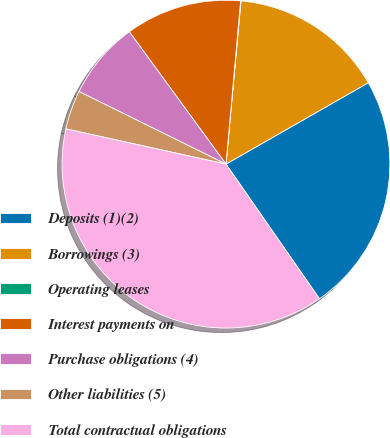Convert chart. <chart><loc_0><loc_0><loc_500><loc_500><pie_chart><fcel>Deposits (1)(2)<fcel>Borrowings (3)<fcel>Operating leases<fcel>Interest payments on<fcel>Purchase obligations (4)<fcel>Other liabilities (5)<fcel>Total contractual obligations<nl><fcel>23.61%<fcel>15.27%<fcel>0.04%<fcel>11.46%<fcel>7.66%<fcel>3.85%<fcel>38.11%<nl></chart> 